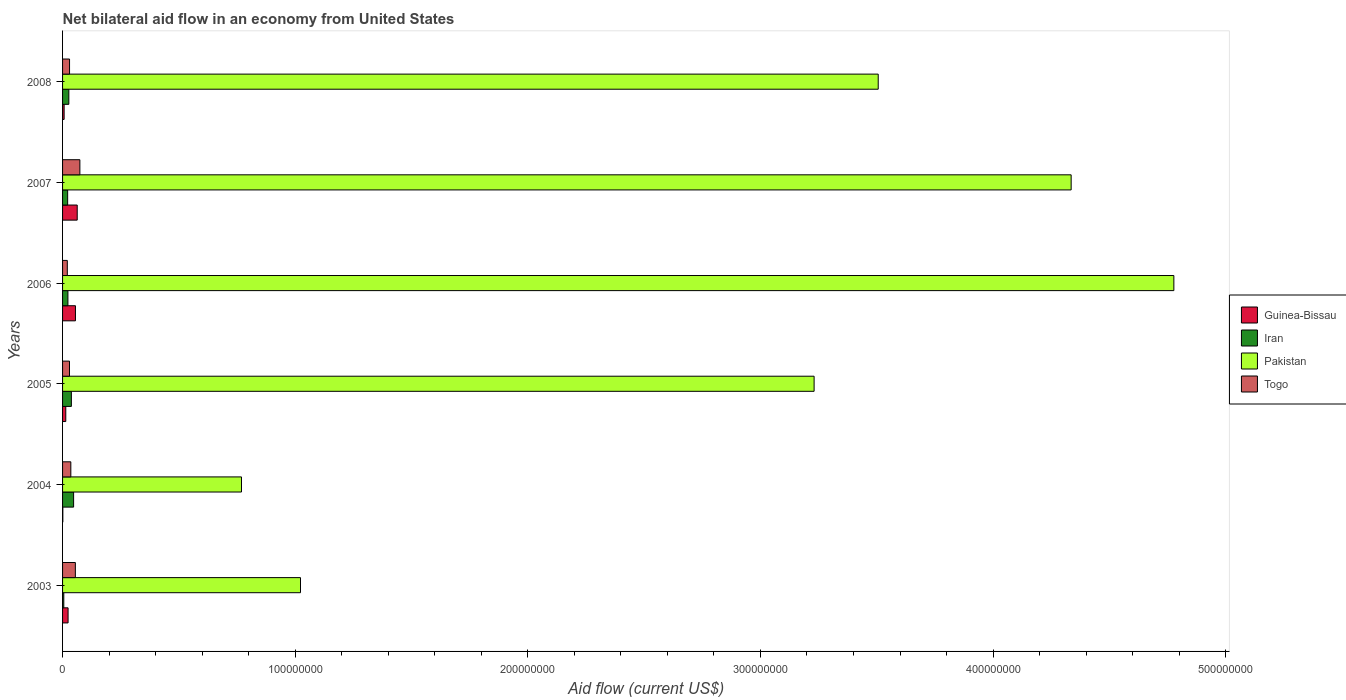What is the label of the 2nd group of bars from the top?
Offer a very short reply. 2007. What is the net bilateral aid flow in Pakistan in 2008?
Provide a short and direct response. 3.51e+08. Across all years, what is the maximum net bilateral aid flow in Iran?
Ensure brevity in your answer.  4.75e+06. Across all years, what is the minimum net bilateral aid flow in Iran?
Provide a short and direct response. 5.30e+05. In which year was the net bilateral aid flow in Togo maximum?
Your response must be concise. 2007. What is the total net bilateral aid flow in Guinea-Bissau in the graph?
Keep it short and to the point. 1.64e+07. What is the difference between the net bilateral aid flow in Iran in 2003 and that in 2006?
Offer a very short reply. -1.77e+06. What is the difference between the net bilateral aid flow in Guinea-Bissau in 2004 and the net bilateral aid flow in Iran in 2007?
Provide a succinct answer. -2.08e+06. What is the average net bilateral aid flow in Guinea-Bissau per year?
Keep it short and to the point. 2.73e+06. In how many years, is the net bilateral aid flow in Togo greater than 260000000 US$?
Provide a short and direct response. 0. What is the ratio of the net bilateral aid flow in Pakistan in 2005 to that in 2007?
Your response must be concise. 0.75. What is the difference between the highest and the second highest net bilateral aid flow in Guinea-Bissau?
Keep it short and to the point. 7.60e+05. What is the difference between the highest and the lowest net bilateral aid flow in Pakistan?
Provide a succinct answer. 4.01e+08. In how many years, is the net bilateral aid flow in Guinea-Bissau greater than the average net bilateral aid flow in Guinea-Bissau taken over all years?
Give a very brief answer. 2. Is the sum of the net bilateral aid flow in Pakistan in 2004 and 2006 greater than the maximum net bilateral aid flow in Guinea-Bissau across all years?
Your answer should be compact. Yes. Is it the case that in every year, the sum of the net bilateral aid flow in Guinea-Bissau and net bilateral aid flow in Iran is greater than the sum of net bilateral aid flow in Pakistan and net bilateral aid flow in Togo?
Your response must be concise. No. What does the 2nd bar from the top in 2008 represents?
Provide a succinct answer. Pakistan. What does the 3rd bar from the bottom in 2007 represents?
Provide a short and direct response. Pakistan. Is it the case that in every year, the sum of the net bilateral aid flow in Pakistan and net bilateral aid flow in Iran is greater than the net bilateral aid flow in Guinea-Bissau?
Your answer should be very brief. Yes. How many bars are there?
Ensure brevity in your answer.  24. Are all the bars in the graph horizontal?
Make the answer very short. Yes. How many years are there in the graph?
Offer a terse response. 6. Does the graph contain any zero values?
Ensure brevity in your answer.  No. Where does the legend appear in the graph?
Ensure brevity in your answer.  Center right. What is the title of the graph?
Offer a terse response. Net bilateral aid flow in an economy from United States. Does "Latin America(developing only)" appear as one of the legend labels in the graph?
Ensure brevity in your answer.  No. What is the label or title of the X-axis?
Provide a short and direct response. Aid flow (current US$). What is the label or title of the Y-axis?
Your answer should be very brief. Years. What is the Aid flow (current US$) in Guinea-Bissau in 2003?
Offer a terse response. 2.37e+06. What is the Aid flow (current US$) in Iran in 2003?
Ensure brevity in your answer.  5.30e+05. What is the Aid flow (current US$) of Pakistan in 2003?
Your response must be concise. 1.02e+08. What is the Aid flow (current US$) of Togo in 2003?
Provide a short and direct response. 5.50e+06. What is the Aid flow (current US$) in Guinea-Bissau in 2004?
Provide a short and direct response. 1.10e+05. What is the Aid flow (current US$) of Iran in 2004?
Make the answer very short. 4.75e+06. What is the Aid flow (current US$) in Pakistan in 2004?
Your answer should be compact. 7.69e+07. What is the Aid flow (current US$) of Togo in 2004?
Your answer should be very brief. 3.55e+06. What is the Aid flow (current US$) of Guinea-Bissau in 2005?
Make the answer very short. 1.38e+06. What is the Aid flow (current US$) in Iran in 2005?
Your response must be concise. 3.79e+06. What is the Aid flow (current US$) in Pakistan in 2005?
Offer a very short reply. 3.23e+08. What is the Aid flow (current US$) of Togo in 2005?
Offer a very short reply. 2.98e+06. What is the Aid flow (current US$) in Guinea-Bissau in 2006?
Offer a very short reply. 5.54e+06. What is the Aid flow (current US$) in Iran in 2006?
Provide a short and direct response. 2.30e+06. What is the Aid flow (current US$) of Pakistan in 2006?
Offer a very short reply. 4.78e+08. What is the Aid flow (current US$) in Togo in 2006?
Provide a succinct answer. 2.04e+06. What is the Aid flow (current US$) of Guinea-Bissau in 2007?
Offer a very short reply. 6.30e+06. What is the Aid flow (current US$) of Iran in 2007?
Provide a succinct answer. 2.19e+06. What is the Aid flow (current US$) of Pakistan in 2007?
Give a very brief answer. 4.34e+08. What is the Aid flow (current US$) of Togo in 2007?
Your answer should be very brief. 7.44e+06. What is the Aid flow (current US$) of Guinea-Bissau in 2008?
Give a very brief answer. 6.70e+05. What is the Aid flow (current US$) of Iran in 2008?
Offer a very short reply. 2.70e+06. What is the Aid flow (current US$) of Pakistan in 2008?
Your answer should be very brief. 3.51e+08. Across all years, what is the maximum Aid flow (current US$) of Guinea-Bissau?
Make the answer very short. 6.30e+06. Across all years, what is the maximum Aid flow (current US$) of Iran?
Keep it short and to the point. 4.75e+06. Across all years, what is the maximum Aid flow (current US$) of Pakistan?
Make the answer very short. 4.78e+08. Across all years, what is the maximum Aid flow (current US$) of Togo?
Offer a very short reply. 7.44e+06. Across all years, what is the minimum Aid flow (current US$) of Guinea-Bissau?
Offer a terse response. 1.10e+05. Across all years, what is the minimum Aid flow (current US$) of Iran?
Your response must be concise. 5.30e+05. Across all years, what is the minimum Aid flow (current US$) of Pakistan?
Give a very brief answer. 7.69e+07. Across all years, what is the minimum Aid flow (current US$) of Togo?
Keep it short and to the point. 2.04e+06. What is the total Aid flow (current US$) of Guinea-Bissau in the graph?
Make the answer very short. 1.64e+07. What is the total Aid flow (current US$) of Iran in the graph?
Ensure brevity in your answer.  1.63e+07. What is the total Aid flow (current US$) of Pakistan in the graph?
Ensure brevity in your answer.  1.76e+09. What is the total Aid flow (current US$) in Togo in the graph?
Offer a very short reply. 2.45e+07. What is the difference between the Aid flow (current US$) in Guinea-Bissau in 2003 and that in 2004?
Give a very brief answer. 2.26e+06. What is the difference between the Aid flow (current US$) in Iran in 2003 and that in 2004?
Your response must be concise. -4.22e+06. What is the difference between the Aid flow (current US$) of Pakistan in 2003 and that in 2004?
Offer a very short reply. 2.54e+07. What is the difference between the Aid flow (current US$) of Togo in 2003 and that in 2004?
Your answer should be compact. 1.95e+06. What is the difference between the Aid flow (current US$) in Guinea-Bissau in 2003 and that in 2005?
Provide a short and direct response. 9.90e+05. What is the difference between the Aid flow (current US$) in Iran in 2003 and that in 2005?
Keep it short and to the point. -3.26e+06. What is the difference between the Aid flow (current US$) of Pakistan in 2003 and that in 2005?
Provide a short and direct response. -2.21e+08. What is the difference between the Aid flow (current US$) in Togo in 2003 and that in 2005?
Your answer should be very brief. 2.52e+06. What is the difference between the Aid flow (current US$) of Guinea-Bissau in 2003 and that in 2006?
Make the answer very short. -3.17e+06. What is the difference between the Aid flow (current US$) in Iran in 2003 and that in 2006?
Offer a terse response. -1.77e+06. What is the difference between the Aid flow (current US$) of Pakistan in 2003 and that in 2006?
Ensure brevity in your answer.  -3.75e+08. What is the difference between the Aid flow (current US$) in Togo in 2003 and that in 2006?
Your answer should be compact. 3.46e+06. What is the difference between the Aid flow (current US$) of Guinea-Bissau in 2003 and that in 2007?
Your response must be concise. -3.93e+06. What is the difference between the Aid flow (current US$) in Iran in 2003 and that in 2007?
Your answer should be compact. -1.66e+06. What is the difference between the Aid flow (current US$) in Pakistan in 2003 and that in 2007?
Ensure brevity in your answer.  -3.31e+08. What is the difference between the Aid flow (current US$) of Togo in 2003 and that in 2007?
Provide a short and direct response. -1.94e+06. What is the difference between the Aid flow (current US$) of Guinea-Bissau in 2003 and that in 2008?
Your answer should be very brief. 1.70e+06. What is the difference between the Aid flow (current US$) of Iran in 2003 and that in 2008?
Make the answer very short. -2.17e+06. What is the difference between the Aid flow (current US$) of Pakistan in 2003 and that in 2008?
Your response must be concise. -2.48e+08. What is the difference between the Aid flow (current US$) in Togo in 2003 and that in 2008?
Provide a short and direct response. 2.50e+06. What is the difference between the Aid flow (current US$) in Guinea-Bissau in 2004 and that in 2005?
Your answer should be very brief. -1.27e+06. What is the difference between the Aid flow (current US$) of Iran in 2004 and that in 2005?
Your response must be concise. 9.60e+05. What is the difference between the Aid flow (current US$) of Pakistan in 2004 and that in 2005?
Provide a short and direct response. -2.46e+08. What is the difference between the Aid flow (current US$) of Togo in 2004 and that in 2005?
Keep it short and to the point. 5.70e+05. What is the difference between the Aid flow (current US$) of Guinea-Bissau in 2004 and that in 2006?
Provide a short and direct response. -5.43e+06. What is the difference between the Aid flow (current US$) in Iran in 2004 and that in 2006?
Your answer should be compact. 2.45e+06. What is the difference between the Aid flow (current US$) in Pakistan in 2004 and that in 2006?
Provide a succinct answer. -4.01e+08. What is the difference between the Aid flow (current US$) of Togo in 2004 and that in 2006?
Make the answer very short. 1.51e+06. What is the difference between the Aid flow (current US$) of Guinea-Bissau in 2004 and that in 2007?
Your answer should be compact. -6.19e+06. What is the difference between the Aid flow (current US$) of Iran in 2004 and that in 2007?
Provide a short and direct response. 2.56e+06. What is the difference between the Aid flow (current US$) in Pakistan in 2004 and that in 2007?
Your answer should be very brief. -3.57e+08. What is the difference between the Aid flow (current US$) in Togo in 2004 and that in 2007?
Provide a succinct answer. -3.89e+06. What is the difference between the Aid flow (current US$) of Guinea-Bissau in 2004 and that in 2008?
Make the answer very short. -5.60e+05. What is the difference between the Aid flow (current US$) in Iran in 2004 and that in 2008?
Ensure brevity in your answer.  2.05e+06. What is the difference between the Aid flow (current US$) of Pakistan in 2004 and that in 2008?
Give a very brief answer. -2.74e+08. What is the difference between the Aid flow (current US$) in Togo in 2004 and that in 2008?
Give a very brief answer. 5.50e+05. What is the difference between the Aid flow (current US$) in Guinea-Bissau in 2005 and that in 2006?
Provide a succinct answer. -4.16e+06. What is the difference between the Aid flow (current US$) in Iran in 2005 and that in 2006?
Provide a short and direct response. 1.49e+06. What is the difference between the Aid flow (current US$) in Pakistan in 2005 and that in 2006?
Your response must be concise. -1.55e+08. What is the difference between the Aid flow (current US$) in Togo in 2005 and that in 2006?
Offer a very short reply. 9.40e+05. What is the difference between the Aid flow (current US$) in Guinea-Bissau in 2005 and that in 2007?
Your answer should be compact. -4.92e+06. What is the difference between the Aid flow (current US$) in Iran in 2005 and that in 2007?
Offer a terse response. 1.60e+06. What is the difference between the Aid flow (current US$) of Pakistan in 2005 and that in 2007?
Your answer should be very brief. -1.10e+08. What is the difference between the Aid flow (current US$) of Togo in 2005 and that in 2007?
Offer a very short reply. -4.46e+06. What is the difference between the Aid flow (current US$) in Guinea-Bissau in 2005 and that in 2008?
Keep it short and to the point. 7.10e+05. What is the difference between the Aid flow (current US$) in Iran in 2005 and that in 2008?
Provide a succinct answer. 1.09e+06. What is the difference between the Aid flow (current US$) in Pakistan in 2005 and that in 2008?
Your answer should be compact. -2.76e+07. What is the difference between the Aid flow (current US$) in Togo in 2005 and that in 2008?
Make the answer very short. -2.00e+04. What is the difference between the Aid flow (current US$) of Guinea-Bissau in 2006 and that in 2007?
Provide a succinct answer. -7.60e+05. What is the difference between the Aid flow (current US$) in Pakistan in 2006 and that in 2007?
Make the answer very short. 4.42e+07. What is the difference between the Aid flow (current US$) in Togo in 2006 and that in 2007?
Provide a short and direct response. -5.40e+06. What is the difference between the Aid flow (current US$) in Guinea-Bissau in 2006 and that in 2008?
Offer a terse response. 4.87e+06. What is the difference between the Aid flow (current US$) of Iran in 2006 and that in 2008?
Make the answer very short. -4.00e+05. What is the difference between the Aid flow (current US$) of Pakistan in 2006 and that in 2008?
Your answer should be very brief. 1.27e+08. What is the difference between the Aid flow (current US$) in Togo in 2006 and that in 2008?
Keep it short and to the point. -9.60e+05. What is the difference between the Aid flow (current US$) in Guinea-Bissau in 2007 and that in 2008?
Offer a very short reply. 5.63e+06. What is the difference between the Aid flow (current US$) of Iran in 2007 and that in 2008?
Ensure brevity in your answer.  -5.10e+05. What is the difference between the Aid flow (current US$) of Pakistan in 2007 and that in 2008?
Your answer should be compact. 8.29e+07. What is the difference between the Aid flow (current US$) of Togo in 2007 and that in 2008?
Provide a succinct answer. 4.44e+06. What is the difference between the Aid flow (current US$) in Guinea-Bissau in 2003 and the Aid flow (current US$) in Iran in 2004?
Offer a terse response. -2.38e+06. What is the difference between the Aid flow (current US$) of Guinea-Bissau in 2003 and the Aid flow (current US$) of Pakistan in 2004?
Offer a very short reply. -7.45e+07. What is the difference between the Aid flow (current US$) in Guinea-Bissau in 2003 and the Aid flow (current US$) in Togo in 2004?
Keep it short and to the point. -1.18e+06. What is the difference between the Aid flow (current US$) of Iran in 2003 and the Aid flow (current US$) of Pakistan in 2004?
Your response must be concise. -7.64e+07. What is the difference between the Aid flow (current US$) in Iran in 2003 and the Aid flow (current US$) in Togo in 2004?
Give a very brief answer. -3.02e+06. What is the difference between the Aid flow (current US$) in Pakistan in 2003 and the Aid flow (current US$) in Togo in 2004?
Offer a very short reply. 9.87e+07. What is the difference between the Aid flow (current US$) in Guinea-Bissau in 2003 and the Aid flow (current US$) in Iran in 2005?
Provide a succinct answer. -1.42e+06. What is the difference between the Aid flow (current US$) of Guinea-Bissau in 2003 and the Aid flow (current US$) of Pakistan in 2005?
Your answer should be compact. -3.21e+08. What is the difference between the Aid flow (current US$) of Guinea-Bissau in 2003 and the Aid flow (current US$) of Togo in 2005?
Offer a terse response. -6.10e+05. What is the difference between the Aid flow (current US$) of Iran in 2003 and the Aid flow (current US$) of Pakistan in 2005?
Keep it short and to the point. -3.23e+08. What is the difference between the Aid flow (current US$) of Iran in 2003 and the Aid flow (current US$) of Togo in 2005?
Ensure brevity in your answer.  -2.45e+06. What is the difference between the Aid flow (current US$) in Pakistan in 2003 and the Aid flow (current US$) in Togo in 2005?
Keep it short and to the point. 9.93e+07. What is the difference between the Aid flow (current US$) of Guinea-Bissau in 2003 and the Aid flow (current US$) of Iran in 2006?
Provide a succinct answer. 7.00e+04. What is the difference between the Aid flow (current US$) in Guinea-Bissau in 2003 and the Aid flow (current US$) in Pakistan in 2006?
Offer a very short reply. -4.75e+08. What is the difference between the Aid flow (current US$) in Guinea-Bissau in 2003 and the Aid flow (current US$) in Togo in 2006?
Make the answer very short. 3.30e+05. What is the difference between the Aid flow (current US$) in Iran in 2003 and the Aid flow (current US$) in Pakistan in 2006?
Ensure brevity in your answer.  -4.77e+08. What is the difference between the Aid flow (current US$) in Iran in 2003 and the Aid flow (current US$) in Togo in 2006?
Your response must be concise. -1.51e+06. What is the difference between the Aid flow (current US$) in Pakistan in 2003 and the Aid flow (current US$) in Togo in 2006?
Your response must be concise. 1.00e+08. What is the difference between the Aid flow (current US$) in Guinea-Bissau in 2003 and the Aid flow (current US$) in Iran in 2007?
Offer a very short reply. 1.80e+05. What is the difference between the Aid flow (current US$) of Guinea-Bissau in 2003 and the Aid flow (current US$) of Pakistan in 2007?
Ensure brevity in your answer.  -4.31e+08. What is the difference between the Aid flow (current US$) of Guinea-Bissau in 2003 and the Aid flow (current US$) of Togo in 2007?
Offer a terse response. -5.07e+06. What is the difference between the Aid flow (current US$) of Iran in 2003 and the Aid flow (current US$) of Pakistan in 2007?
Offer a very short reply. -4.33e+08. What is the difference between the Aid flow (current US$) in Iran in 2003 and the Aid flow (current US$) in Togo in 2007?
Provide a succinct answer. -6.91e+06. What is the difference between the Aid flow (current US$) in Pakistan in 2003 and the Aid flow (current US$) in Togo in 2007?
Provide a succinct answer. 9.48e+07. What is the difference between the Aid flow (current US$) of Guinea-Bissau in 2003 and the Aid flow (current US$) of Iran in 2008?
Offer a very short reply. -3.30e+05. What is the difference between the Aid flow (current US$) of Guinea-Bissau in 2003 and the Aid flow (current US$) of Pakistan in 2008?
Offer a very short reply. -3.48e+08. What is the difference between the Aid flow (current US$) of Guinea-Bissau in 2003 and the Aid flow (current US$) of Togo in 2008?
Your answer should be compact. -6.30e+05. What is the difference between the Aid flow (current US$) of Iran in 2003 and the Aid flow (current US$) of Pakistan in 2008?
Give a very brief answer. -3.50e+08. What is the difference between the Aid flow (current US$) of Iran in 2003 and the Aid flow (current US$) of Togo in 2008?
Your response must be concise. -2.47e+06. What is the difference between the Aid flow (current US$) of Pakistan in 2003 and the Aid flow (current US$) of Togo in 2008?
Your response must be concise. 9.93e+07. What is the difference between the Aid flow (current US$) of Guinea-Bissau in 2004 and the Aid flow (current US$) of Iran in 2005?
Your answer should be compact. -3.68e+06. What is the difference between the Aid flow (current US$) of Guinea-Bissau in 2004 and the Aid flow (current US$) of Pakistan in 2005?
Your answer should be very brief. -3.23e+08. What is the difference between the Aid flow (current US$) of Guinea-Bissau in 2004 and the Aid flow (current US$) of Togo in 2005?
Keep it short and to the point. -2.87e+06. What is the difference between the Aid flow (current US$) of Iran in 2004 and the Aid flow (current US$) of Pakistan in 2005?
Offer a terse response. -3.18e+08. What is the difference between the Aid flow (current US$) in Iran in 2004 and the Aid flow (current US$) in Togo in 2005?
Provide a succinct answer. 1.77e+06. What is the difference between the Aid flow (current US$) of Pakistan in 2004 and the Aid flow (current US$) of Togo in 2005?
Ensure brevity in your answer.  7.39e+07. What is the difference between the Aid flow (current US$) of Guinea-Bissau in 2004 and the Aid flow (current US$) of Iran in 2006?
Provide a succinct answer. -2.19e+06. What is the difference between the Aid flow (current US$) in Guinea-Bissau in 2004 and the Aid flow (current US$) in Pakistan in 2006?
Your answer should be very brief. -4.78e+08. What is the difference between the Aid flow (current US$) in Guinea-Bissau in 2004 and the Aid flow (current US$) in Togo in 2006?
Provide a short and direct response. -1.93e+06. What is the difference between the Aid flow (current US$) in Iran in 2004 and the Aid flow (current US$) in Pakistan in 2006?
Your answer should be compact. -4.73e+08. What is the difference between the Aid flow (current US$) in Iran in 2004 and the Aid flow (current US$) in Togo in 2006?
Offer a terse response. 2.71e+06. What is the difference between the Aid flow (current US$) of Pakistan in 2004 and the Aid flow (current US$) of Togo in 2006?
Make the answer very short. 7.49e+07. What is the difference between the Aid flow (current US$) of Guinea-Bissau in 2004 and the Aid flow (current US$) of Iran in 2007?
Provide a short and direct response. -2.08e+06. What is the difference between the Aid flow (current US$) of Guinea-Bissau in 2004 and the Aid flow (current US$) of Pakistan in 2007?
Make the answer very short. -4.33e+08. What is the difference between the Aid flow (current US$) in Guinea-Bissau in 2004 and the Aid flow (current US$) in Togo in 2007?
Provide a succinct answer. -7.33e+06. What is the difference between the Aid flow (current US$) in Iran in 2004 and the Aid flow (current US$) in Pakistan in 2007?
Make the answer very short. -4.29e+08. What is the difference between the Aid flow (current US$) of Iran in 2004 and the Aid flow (current US$) of Togo in 2007?
Your answer should be compact. -2.69e+06. What is the difference between the Aid flow (current US$) in Pakistan in 2004 and the Aid flow (current US$) in Togo in 2007?
Make the answer very short. 6.95e+07. What is the difference between the Aid flow (current US$) of Guinea-Bissau in 2004 and the Aid flow (current US$) of Iran in 2008?
Keep it short and to the point. -2.59e+06. What is the difference between the Aid flow (current US$) in Guinea-Bissau in 2004 and the Aid flow (current US$) in Pakistan in 2008?
Give a very brief answer. -3.51e+08. What is the difference between the Aid flow (current US$) in Guinea-Bissau in 2004 and the Aid flow (current US$) in Togo in 2008?
Make the answer very short. -2.89e+06. What is the difference between the Aid flow (current US$) in Iran in 2004 and the Aid flow (current US$) in Pakistan in 2008?
Your answer should be compact. -3.46e+08. What is the difference between the Aid flow (current US$) of Iran in 2004 and the Aid flow (current US$) of Togo in 2008?
Give a very brief answer. 1.75e+06. What is the difference between the Aid flow (current US$) in Pakistan in 2004 and the Aid flow (current US$) in Togo in 2008?
Make the answer very short. 7.39e+07. What is the difference between the Aid flow (current US$) of Guinea-Bissau in 2005 and the Aid flow (current US$) of Iran in 2006?
Your answer should be very brief. -9.20e+05. What is the difference between the Aid flow (current US$) in Guinea-Bissau in 2005 and the Aid flow (current US$) in Pakistan in 2006?
Offer a very short reply. -4.76e+08. What is the difference between the Aid flow (current US$) in Guinea-Bissau in 2005 and the Aid flow (current US$) in Togo in 2006?
Your answer should be very brief. -6.60e+05. What is the difference between the Aid flow (current US$) of Iran in 2005 and the Aid flow (current US$) of Pakistan in 2006?
Provide a succinct answer. -4.74e+08. What is the difference between the Aid flow (current US$) in Iran in 2005 and the Aid flow (current US$) in Togo in 2006?
Give a very brief answer. 1.75e+06. What is the difference between the Aid flow (current US$) in Pakistan in 2005 and the Aid flow (current US$) in Togo in 2006?
Your answer should be very brief. 3.21e+08. What is the difference between the Aid flow (current US$) in Guinea-Bissau in 2005 and the Aid flow (current US$) in Iran in 2007?
Provide a short and direct response. -8.10e+05. What is the difference between the Aid flow (current US$) in Guinea-Bissau in 2005 and the Aid flow (current US$) in Pakistan in 2007?
Your answer should be compact. -4.32e+08. What is the difference between the Aid flow (current US$) of Guinea-Bissau in 2005 and the Aid flow (current US$) of Togo in 2007?
Your answer should be compact. -6.06e+06. What is the difference between the Aid flow (current US$) in Iran in 2005 and the Aid flow (current US$) in Pakistan in 2007?
Your response must be concise. -4.30e+08. What is the difference between the Aid flow (current US$) in Iran in 2005 and the Aid flow (current US$) in Togo in 2007?
Your answer should be very brief. -3.65e+06. What is the difference between the Aid flow (current US$) of Pakistan in 2005 and the Aid flow (current US$) of Togo in 2007?
Your response must be concise. 3.16e+08. What is the difference between the Aid flow (current US$) of Guinea-Bissau in 2005 and the Aid flow (current US$) of Iran in 2008?
Ensure brevity in your answer.  -1.32e+06. What is the difference between the Aid flow (current US$) of Guinea-Bissau in 2005 and the Aid flow (current US$) of Pakistan in 2008?
Provide a succinct answer. -3.49e+08. What is the difference between the Aid flow (current US$) of Guinea-Bissau in 2005 and the Aid flow (current US$) of Togo in 2008?
Provide a short and direct response. -1.62e+06. What is the difference between the Aid flow (current US$) in Iran in 2005 and the Aid flow (current US$) in Pakistan in 2008?
Provide a succinct answer. -3.47e+08. What is the difference between the Aid flow (current US$) of Iran in 2005 and the Aid flow (current US$) of Togo in 2008?
Provide a succinct answer. 7.90e+05. What is the difference between the Aid flow (current US$) in Pakistan in 2005 and the Aid flow (current US$) in Togo in 2008?
Offer a terse response. 3.20e+08. What is the difference between the Aid flow (current US$) of Guinea-Bissau in 2006 and the Aid flow (current US$) of Iran in 2007?
Ensure brevity in your answer.  3.35e+06. What is the difference between the Aid flow (current US$) of Guinea-Bissau in 2006 and the Aid flow (current US$) of Pakistan in 2007?
Ensure brevity in your answer.  -4.28e+08. What is the difference between the Aid flow (current US$) of Guinea-Bissau in 2006 and the Aid flow (current US$) of Togo in 2007?
Provide a succinct answer. -1.90e+06. What is the difference between the Aid flow (current US$) in Iran in 2006 and the Aid flow (current US$) in Pakistan in 2007?
Provide a short and direct response. -4.31e+08. What is the difference between the Aid flow (current US$) of Iran in 2006 and the Aid flow (current US$) of Togo in 2007?
Make the answer very short. -5.14e+06. What is the difference between the Aid flow (current US$) of Pakistan in 2006 and the Aid flow (current US$) of Togo in 2007?
Give a very brief answer. 4.70e+08. What is the difference between the Aid flow (current US$) of Guinea-Bissau in 2006 and the Aid flow (current US$) of Iran in 2008?
Your response must be concise. 2.84e+06. What is the difference between the Aid flow (current US$) in Guinea-Bissau in 2006 and the Aid flow (current US$) in Pakistan in 2008?
Your response must be concise. -3.45e+08. What is the difference between the Aid flow (current US$) of Guinea-Bissau in 2006 and the Aid flow (current US$) of Togo in 2008?
Provide a succinct answer. 2.54e+06. What is the difference between the Aid flow (current US$) in Iran in 2006 and the Aid flow (current US$) in Pakistan in 2008?
Your answer should be compact. -3.48e+08. What is the difference between the Aid flow (current US$) in Iran in 2006 and the Aid flow (current US$) in Togo in 2008?
Your response must be concise. -7.00e+05. What is the difference between the Aid flow (current US$) of Pakistan in 2006 and the Aid flow (current US$) of Togo in 2008?
Offer a very short reply. 4.75e+08. What is the difference between the Aid flow (current US$) in Guinea-Bissau in 2007 and the Aid flow (current US$) in Iran in 2008?
Provide a succinct answer. 3.60e+06. What is the difference between the Aid flow (current US$) of Guinea-Bissau in 2007 and the Aid flow (current US$) of Pakistan in 2008?
Give a very brief answer. -3.44e+08. What is the difference between the Aid flow (current US$) in Guinea-Bissau in 2007 and the Aid flow (current US$) in Togo in 2008?
Make the answer very short. 3.30e+06. What is the difference between the Aid flow (current US$) of Iran in 2007 and the Aid flow (current US$) of Pakistan in 2008?
Your answer should be compact. -3.48e+08. What is the difference between the Aid flow (current US$) of Iran in 2007 and the Aid flow (current US$) of Togo in 2008?
Your response must be concise. -8.10e+05. What is the difference between the Aid flow (current US$) in Pakistan in 2007 and the Aid flow (current US$) in Togo in 2008?
Your answer should be very brief. 4.31e+08. What is the average Aid flow (current US$) of Guinea-Bissau per year?
Keep it short and to the point. 2.73e+06. What is the average Aid flow (current US$) of Iran per year?
Offer a very short reply. 2.71e+06. What is the average Aid flow (current US$) of Pakistan per year?
Offer a terse response. 2.94e+08. What is the average Aid flow (current US$) of Togo per year?
Provide a short and direct response. 4.08e+06. In the year 2003, what is the difference between the Aid flow (current US$) of Guinea-Bissau and Aid flow (current US$) of Iran?
Your answer should be very brief. 1.84e+06. In the year 2003, what is the difference between the Aid flow (current US$) in Guinea-Bissau and Aid flow (current US$) in Pakistan?
Provide a short and direct response. -9.99e+07. In the year 2003, what is the difference between the Aid flow (current US$) of Guinea-Bissau and Aid flow (current US$) of Togo?
Offer a terse response. -3.13e+06. In the year 2003, what is the difference between the Aid flow (current US$) in Iran and Aid flow (current US$) in Pakistan?
Offer a very short reply. -1.02e+08. In the year 2003, what is the difference between the Aid flow (current US$) in Iran and Aid flow (current US$) in Togo?
Give a very brief answer. -4.97e+06. In the year 2003, what is the difference between the Aid flow (current US$) in Pakistan and Aid flow (current US$) in Togo?
Your answer should be very brief. 9.68e+07. In the year 2004, what is the difference between the Aid flow (current US$) of Guinea-Bissau and Aid flow (current US$) of Iran?
Your answer should be very brief. -4.64e+06. In the year 2004, what is the difference between the Aid flow (current US$) in Guinea-Bissau and Aid flow (current US$) in Pakistan?
Offer a terse response. -7.68e+07. In the year 2004, what is the difference between the Aid flow (current US$) in Guinea-Bissau and Aid flow (current US$) in Togo?
Ensure brevity in your answer.  -3.44e+06. In the year 2004, what is the difference between the Aid flow (current US$) of Iran and Aid flow (current US$) of Pakistan?
Ensure brevity in your answer.  -7.22e+07. In the year 2004, what is the difference between the Aid flow (current US$) in Iran and Aid flow (current US$) in Togo?
Offer a terse response. 1.20e+06. In the year 2004, what is the difference between the Aid flow (current US$) of Pakistan and Aid flow (current US$) of Togo?
Your answer should be compact. 7.34e+07. In the year 2005, what is the difference between the Aid flow (current US$) of Guinea-Bissau and Aid flow (current US$) of Iran?
Keep it short and to the point. -2.41e+06. In the year 2005, what is the difference between the Aid flow (current US$) in Guinea-Bissau and Aid flow (current US$) in Pakistan?
Keep it short and to the point. -3.22e+08. In the year 2005, what is the difference between the Aid flow (current US$) in Guinea-Bissau and Aid flow (current US$) in Togo?
Offer a terse response. -1.60e+06. In the year 2005, what is the difference between the Aid flow (current US$) in Iran and Aid flow (current US$) in Pakistan?
Give a very brief answer. -3.19e+08. In the year 2005, what is the difference between the Aid flow (current US$) in Iran and Aid flow (current US$) in Togo?
Give a very brief answer. 8.10e+05. In the year 2005, what is the difference between the Aid flow (current US$) of Pakistan and Aid flow (current US$) of Togo?
Your response must be concise. 3.20e+08. In the year 2006, what is the difference between the Aid flow (current US$) of Guinea-Bissau and Aid flow (current US$) of Iran?
Ensure brevity in your answer.  3.24e+06. In the year 2006, what is the difference between the Aid flow (current US$) in Guinea-Bissau and Aid flow (current US$) in Pakistan?
Offer a terse response. -4.72e+08. In the year 2006, what is the difference between the Aid flow (current US$) in Guinea-Bissau and Aid flow (current US$) in Togo?
Your response must be concise. 3.50e+06. In the year 2006, what is the difference between the Aid flow (current US$) in Iran and Aid flow (current US$) in Pakistan?
Offer a terse response. -4.75e+08. In the year 2006, what is the difference between the Aid flow (current US$) in Iran and Aid flow (current US$) in Togo?
Provide a succinct answer. 2.60e+05. In the year 2006, what is the difference between the Aid flow (current US$) of Pakistan and Aid flow (current US$) of Togo?
Offer a very short reply. 4.76e+08. In the year 2007, what is the difference between the Aid flow (current US$) in Guinea-Bissau and Aid flow (current US$) in Iran?
Your answer should be compact. 4.11e+06. In the year 2007, what is the difference between the Aid flow (current US$) in Guinea-Bissau and Aid flow (current US$) in Pakistan?
Your answer should be very brief. -4.27e+08. In the year 2007, what is the difference between the Aid flow (current US$) in Guinea-Bissau and Aid flow (current US$) in Togo?
Ensure brevity in your answer.  -1.14e+06. In the year 2007, what is the difference between the Aid flow (current US$) of Iran and Aid flow (current US$) of Pakistan?
Make the answer very short. -4.31e+08. In the year 2007, what is the difference between the Aid flow (current US$) in Iran and Aid flow (current US$) in Togo?
Ensure brevity in your answer.  -5.25e+06. In the year 2007, what is the difference between the Aid flow (current US$) of Pakistan and Aid flow (current US$) of Togo?
Keep it short and to the point. 4.26e+08. In the year 2008, what is the difference between the Aid flow (current US$) of Guinea-Bissau and Aid flow (current US$) of Iran?
Ensure brevity in your answer.  -2.03e+06. In the year 2008, what is the difference between the Aid flow (current US$) of Guinea-Bissau and Aid flow (current US$) of Pakistan?
Offer a terse response. -3.50e+08. In the year 2008, what is the difference between the Aid flow (current US$) in Guinea-Bissau and Aid flow (current US$) in Togo?
Your response must be concise. -2.33e+06. In the year 2008, what is the difference between the Aid flow (current US$) of Iran and Aid flow (current US$) of Pakistan?
Keep it short and to the point. -3.48e+08. In the year 2008, what is the difference between the Aid flow (current US$) in Pakistan and Aid flow (current US$) in Togo?
Your answer should be compact. 3.48e+08. What is the ratio of the Aid flow (current US$) in Guinea-Bissau in 2003 to that in 2004?
Make the answer very short. 21.55. What is the ratio of the Aid flow (current US$) of Iran in 2003 to that in 2004?
Keep it short and to the point. 0.11. What is the ratio of the Aid flow (current US$) of Pakistan in 2003 to that in 2004?
Your answer should be very brief. 1.33. What is the ratio of the Aid flow (current US$) of Togo in 2003 to that in 2004?
Make the answer very short. 1.55. What is the ratio of the Aid flow (current US$) in Guinea-Bissau in 2003 to that in 2005?
Make the answer very short. 1.72. What is the ratio of the Aid flow (current US$) in Iran in 2003 to that in 2005?
Keep it short and to the point. 0.14. What is the ratio of the Aid flow (current US$) of Pakistan in 2003 to that in 2005?
Ensure brevity in your answer.  0.32. What is the ratio of the Aid flow (current US$) of Togo in 2003 to that in 2005?
Offer a terse response. 1.85. What is the ratio of the Aid flow (current US$) in Guinea-Bissau in 2003 to that in 2006?
Make the answer very short. 0.43. What is the ratio of the Aid flow (current US$) of Iran in 2003 to that in 2006?
Your answer should be compact. 0.23. What is the ratio of the Aid flow (current US$) of Pakistan in 2003 to that in 2006?
Ensure brevity in your answer.  0.21. What is the ratio of the Aid flow (current US$) of Togo in 2003 to that in 2006?
Offer a terse response. 2.7. What is the ratio of the Aid flow (current US$) in Guinea-Bissau in 2003 to that in 2007?
Keep it short and to the point. 0.38. What is the ratio of the Aid flow (current US$) of Iran in 2003 to that in 2007?
Your response must be concise. 0.24. What is the ratio of the Aid flow (current US$) in Pakistan in 2003 to that in 2007?
Offer a very short reply. 0.24. What is the ratio of the Aid flow (current US$) of Togo in 2003 to that in 2007?
Your answer should be very brief. 0.74. What is the ratio of the Aid flow (current US$) of Guinea-Bissau in 2003 to that in 2008?
Ensure brevity in your answer.  3.54. What is the ratio of the Aid flow (current US$) in Iran in 2003 to that in 2008?
Offer a terse response. 0.2. What is the ratio of the Aid flow (current US$) of Pakistan in 2003 to that in 2008?
Offer a very short reply. 0.29. What is the ratio of the Aid flow (current US$) of Togo in 2003 to that in 2008?
Your response must be concise. 1.83. What is the ratio of the Aid flow (current US$) of Guinea-Bissau in 2004 to that in 2005?
Offer a terse response. 0.08. What is the ratio of the Aid flow (current US$) of Iran in 2004 to that in 2005?
Offer a very short reply. 1.25. What is the ratio of the Aid flow (current US$) of Pakistan in 2004 to that in 2005?
Your response must be concise. 0.24. What is the ratio of the Aid flow (current US$) of Togo in 2004 to that in 2005?
Give a very brief answer. 1.19. What is the ratio of the Aid flow (current US$) in Guinea-Bissau in 2004 to that in 2006?
Your response must be concise. 0.02. What is the ratio of the Aid flow (current US$) of Iran in 2004 to that in 2006?
Offer a very short reply. 2.07. What is the ratio of the Aid flow (current US$) of Pakistan in 2004 to that in 2006?
Give a very brief answer. 0.16. What is the ratio of the Aid flow (current US$) in Togo in 2004 to that in 2006?
Your answer should be very brief. 1.74. What is the ratio of the Aid flow (current US$) of Guinea-Bissau in 2004 to that in 2007?
Give a very brief answer. 0.02. What is the ratio of the Aid flow (current US$) of Iran in 2004 to that in 2007?
Your answer should be compact. 2.17. What is the ratio of the Aid flow (current US$) in Pakistan in 2004 to that in 2007?
Keep it short and to the point. 0.18. What is the ratio of the Aid flow (current US$) in Togo in 2004 to that in 2007?
Provide a succinct answer. 0.48. What is the ratio of the Aid flow (current US$) of Guinea-Bissau in 2004 to that in 2008?
Provide a succinct answer. 0.16. What is the ratio of the Aid flow (current US$) in Iran in 2004 to that in 2008?
Ensure brevity in your answer.  1.76. What is the ratio of the Aid flow (current US$) in Pakistan in 2004 to that in 2008?
Provide a short and direct response. 0.22. What is the ratio of the Aid flow (current US$) of Togo in 2004 to that in 2008?
Ensure brevity in your answer.  1.18. What is the ratio of the Aid flow (current US$) of Guinea-Bissau in 2005 to that in 2006?
Provide a succinct answer. 0.25. What is the ratio of the Aid flow (current US$) in Iran in 2005 to that in 2006?
Offer a very short reply. 1.65. What is the ratio of the Aid flow (current US$) in Pakistan in 2005 to that in 2006?
Provide a succinct answer. 0.68. What is the ratio of the Aid flow (current US$) in Togo in 2005 to that in 2006?
Keep it short and to the point. 1.46. What is the ratio of the Aid flow (current US$) in Guinea-Bissau in 2005 to that in 2007?
Offer a terse response. 0.22. What is the ratio of the Aid flow (current US$) of Iran in 2005 to that in 2007?
Offer a terse response. 1.73. What is the ratio of the Aid flow (current US$) of Pakistan in 2005 to that in 2007?
Your response must be concise. 0.75. What is the ratio of the Aid flow (current US$) of Togo in 2005 to that in 2007?
Provide a short and direct response. 0.4. What is the ratio of the Aid flow (current US$) in Guinea-Bissau in 2005 to that in 2008?
Provide a succinct answer. 2.06. What is the ratio of the Aid flow (current US$) in Iran in 2005 to that in 2008?
Your response must be concise. 1.4. What is the ratio of the Aid flow (current US$) in Pakistan in 2005 to that in 2008?
Give a very brief answer. 0.92. What is the ratio of the Aid flow (current US$) of Togo in 2005 to that in 2008?
Your answer should be very brief. 0.99. What is the ratio of the Aid flow (current US$) in Guinea-Bissau in 2006 to that in 2007?
Give a very brief answer. 0.88. What is the ratio of the Aid flow (current US$) in Iran in 2006 to that in 2007?
Ensure brevity in your answer.  1.05. What is the ratio of the Aid flow (current US$) of Pakistan in 2006 to that in 2007?
Offer a terse response. 1.1. What is the ratio of the Aid flow (current US$) of Togo in 2006 to that in 2007?
Make the answer very short. 0.27. What is the ratio of the Aid flow (current US$) of Guinea-Bissau in 2006 to that in 2008?
Your answer should be very brief. 8.27. What is the ratio of the Aid flow (current US$) in Iran in 2006 to that in 2008?
Ensure brevity in your answer.  0.85. What is the ratio of the Aid flow (current US$) in Pakistan in 2006 to that in 2008?
Your answer should be very brief. 1.36. What is the ratio of the Aid flow (current US$) in Togo in 2006 to that in 2008?
Ensure brevity in your answer.  0.68. What is the ratio of the Aid flow (current US$) in Guinea-Bissau in 2007 to that in 2008?
Provide a succinct answer. 9.4. What is the ratio of the Aid flow (current US$) of Iran in 2007 to that in 2008?
Make the answer very short. 0.81. What is the ratio of the Aid flow (current US$) in Pakistan in 2007 to that in 2008?
Offer a very short reply. 1.24. What is the ratio of the Aid flow (current US$) in Togo in 2007 to that in 2008?
Provide a short and direct response. 2.48. What is the difference between the highest and the second highest Aid flow (current US$) in Guinea-Bissau?
Make the answer very short. 7.60e+05. What is the difference between the highest and the second highest Aid flow (current US$) of Iran?
Ensure brevity in your answer.  9.60e+05. What is the difference between the highest and the second highest Aid flow (current US$) in Pakistan?
Your answer should be very brief. 4.42e+07. What is the difference between the highest and the second highest Aid flow (current US$) in Togo?
Keep it short and to the point. 1.94e+06. What is the difference between the highest and the lowest Aid flow (current US$) in Guinea-Bissau?
Make the answer very short. 6.19e+06. What is the difference between the highest and the lowest Aid flow (current US$) of Iran?
Make the answer very short. 4.22e+06. What is the difference between the highest and the lowest Aid flow (current US$) in Pakistan?
Your answer should be very brief. 4.01e+08. What is the difference between the highest and the lowest Aid flow (current US$) of Togo?
Your answer should be very brief. 5.40e+06. 